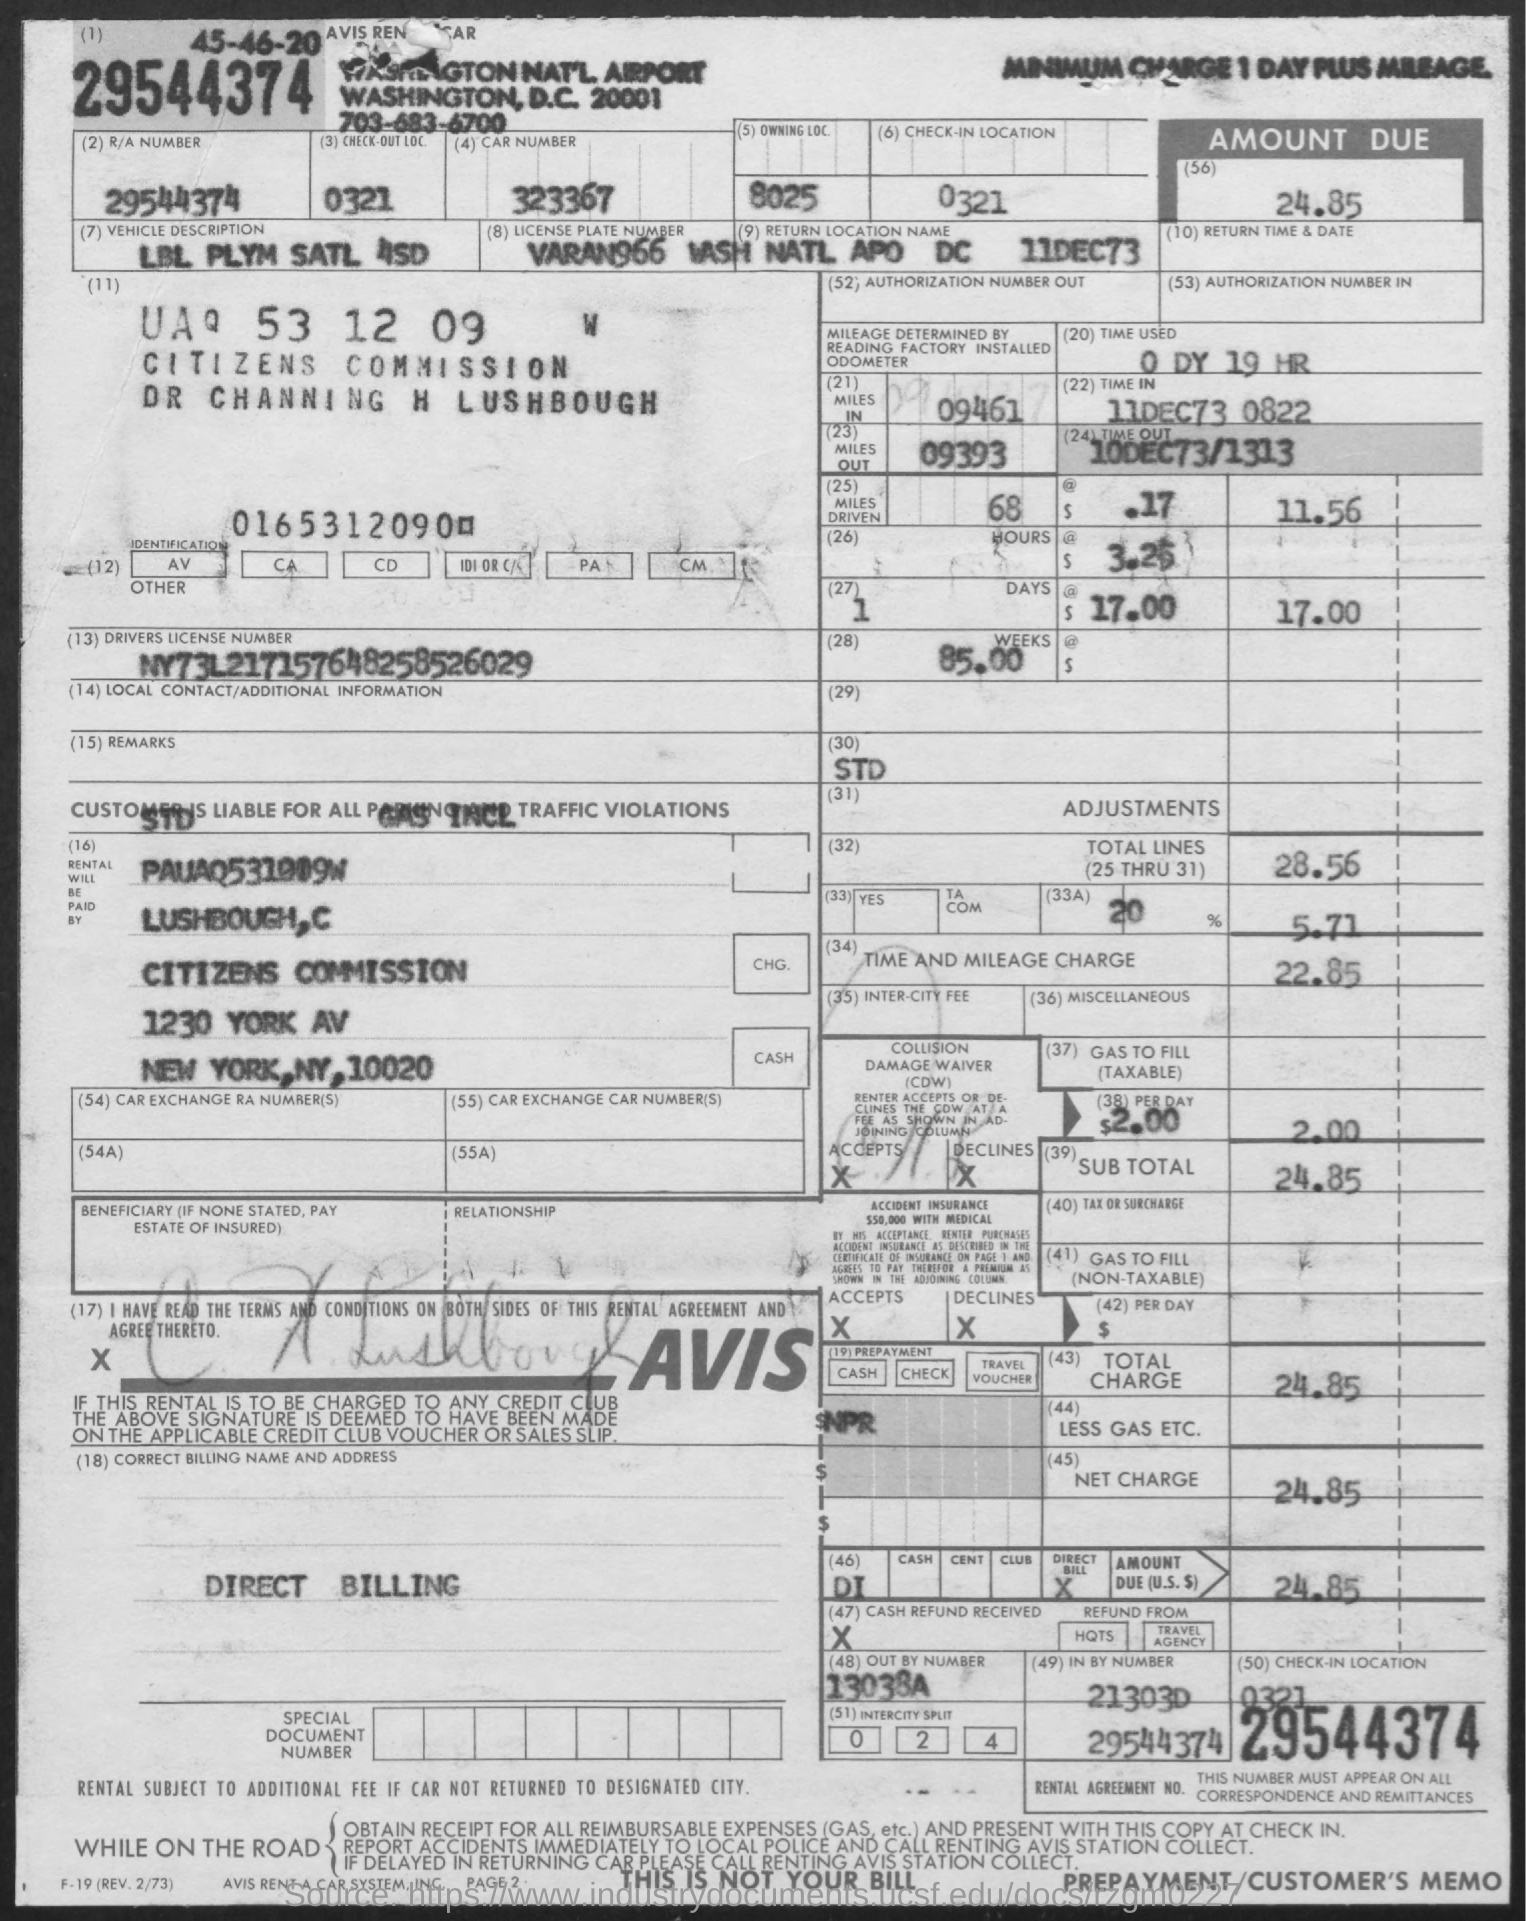List a handful of essential elements in this visual. The document indicates that an amount of 24.85 is due. The driver's license number contained in the document is NY73L217157648258526029. The document describes a vehicle with the following features: a LBL PLYM SATL 4SD description. The provided car number is 323367... The time and mileage charge is 22.85. 